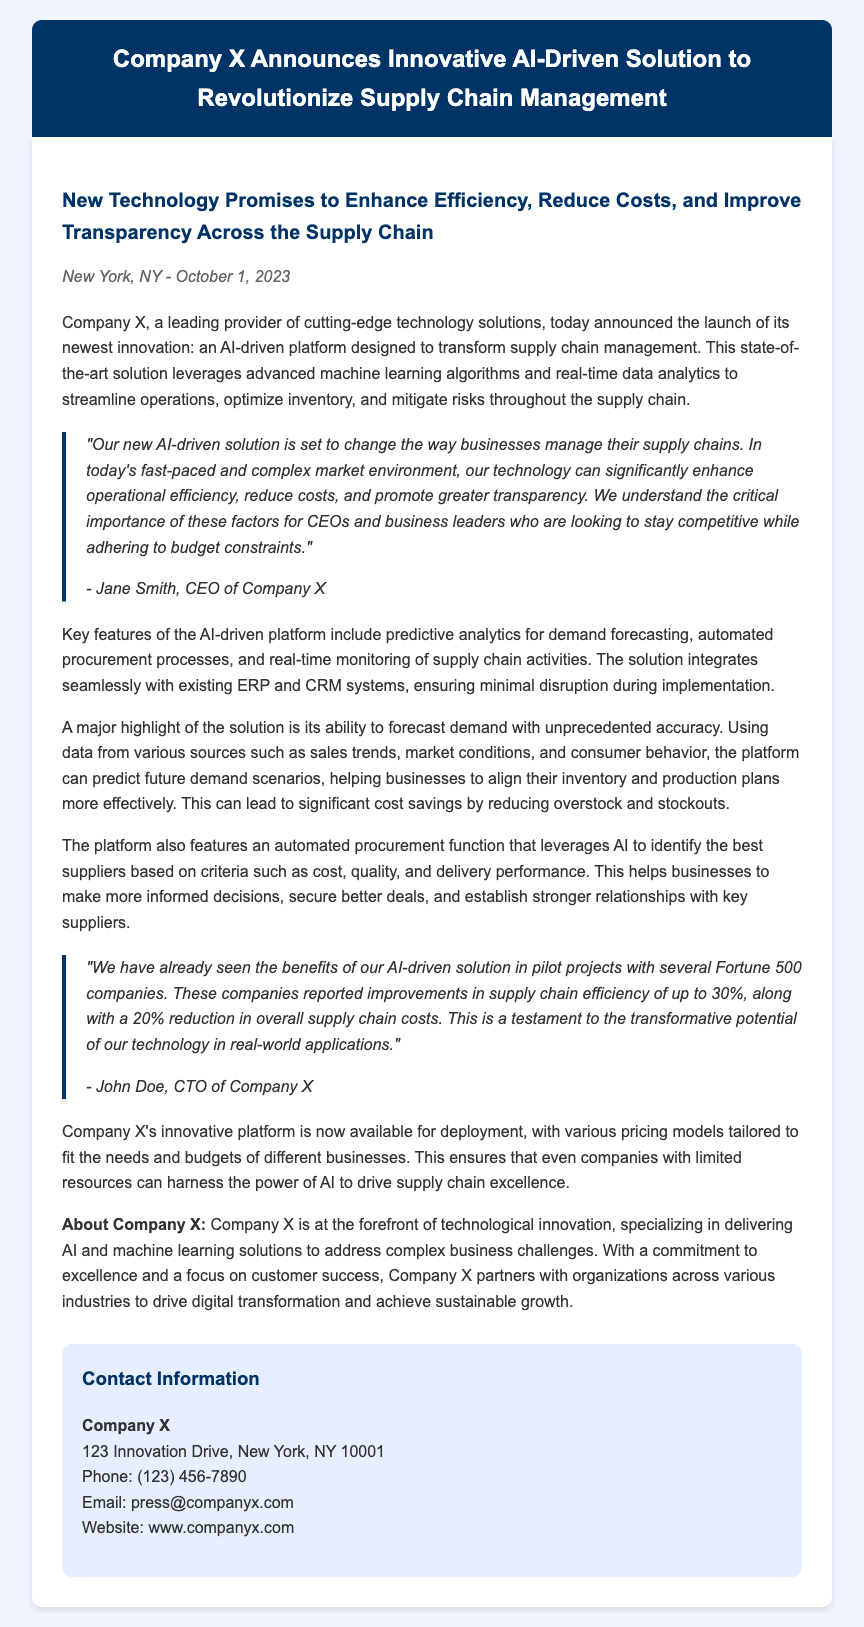What is the date of the announcement? The date of the announcement is mentioned in the dateline section of the document.
Answer: October 1, 2023 Who is the CEO of Company X? The CEO is quoted in the press release, providing key insights about the new solution.
Answer: Jane Smith What is one key benefit of the AI-driven platform? The document outlines several benefits, one of which is specifically highlighted in the content.
Answer: Enhance efficiency What percentage improvement in supply chain efficiency was reported? The document provides a specific percentage gain after pilot projects with clients.
Answer: 30% What type of analytics does the platform use for demand forecasting? The solution's capability in forecasting is described in the content section.
Answer: Predictive analytics What is the primary focus of Company X? The closing section of the document describes the main area of specialization for Company X.
Answer: Technological innovation How many Fortune 500 companies participated in pilot projects? The document explicitly mentions the involvement of these companies in assessing the solution's effectiveness.
Answer: Several What aspect of procurement does the solution automate? The features of the AI-driven platform are clearly outlined, including automation in this specific area.
Answer: Procurement processes 